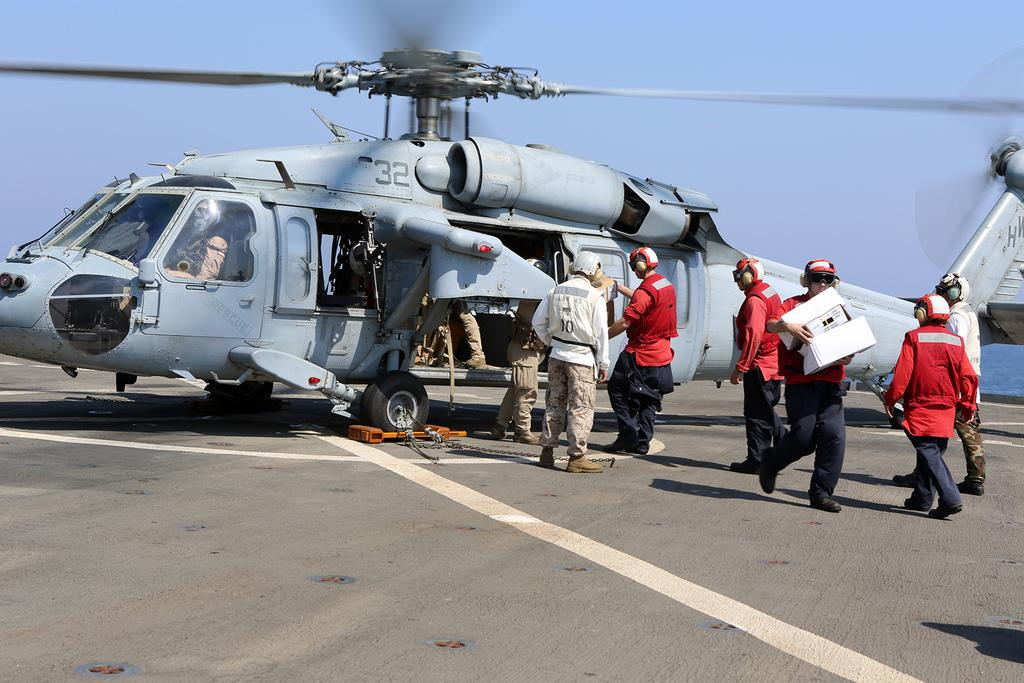What type of vehicle is on the helipad in the image? There is a helicopter on a helipad in the image. What else can be seen in the image besides the helicopter? There is a group of people standing in the image. What is visible in the background of the image? The sky is visible in the background of the image. What type of loaf is being baked by the helicopter in the image? There is no loaf being baked by the helicopter in the image; it is a helicopter on a helipad. 